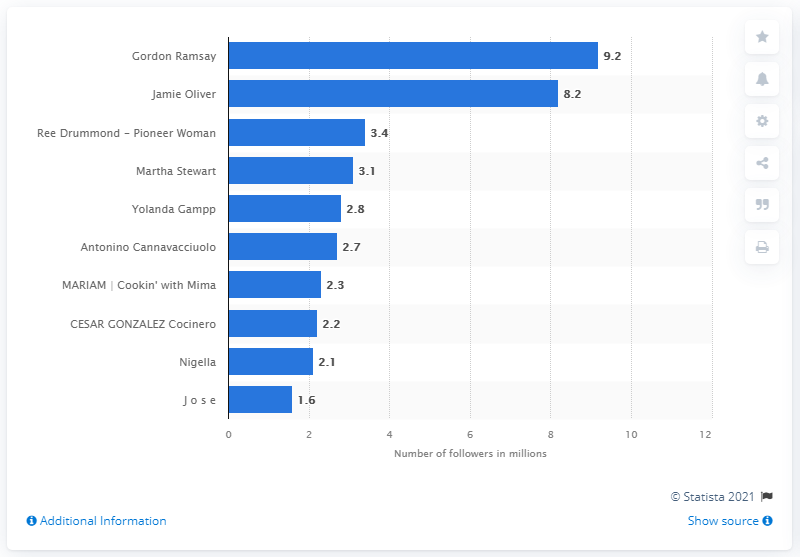Specify some key components in this picture. Gordon Ramsay is the most followed food influencer on Instagram. 